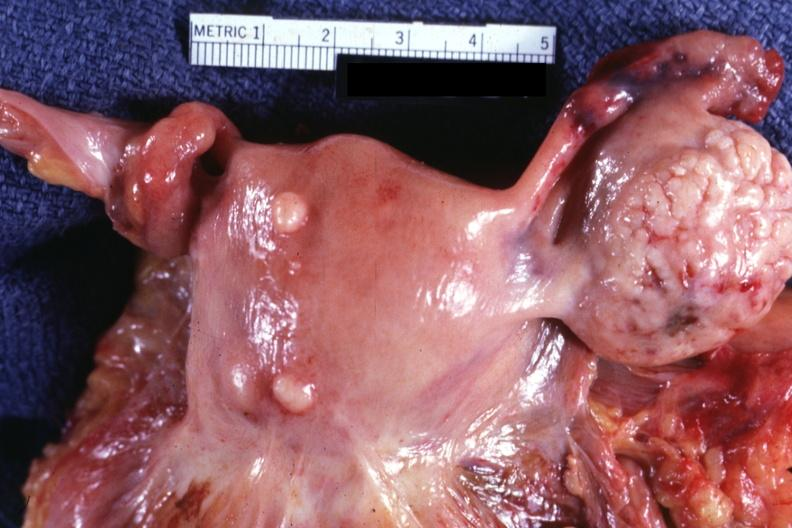how are intramural one lesion normal ovary is in photo?
Answer the question using a single word or phrase. Small 